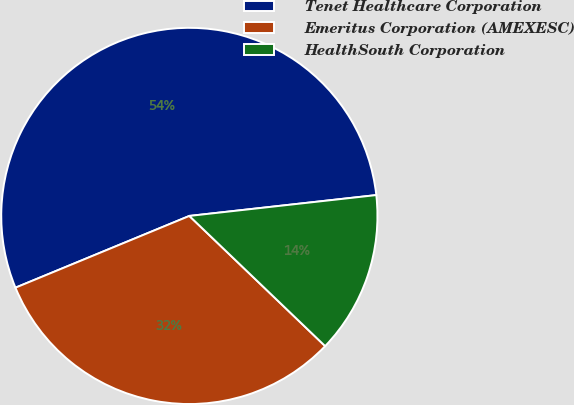Convert chart to OTSL. <chart><loc_0><loc_0><loc_500><loc_500><pie_chart><fcel>Tenet Healthcare Corporation<fcel>Emeritus Corporation (AMEXESC)<fcel>HealthSouth Corporation<nl><fcel>54.46%<fcel>31.61%<fcel>13.93%<nl></chart> 